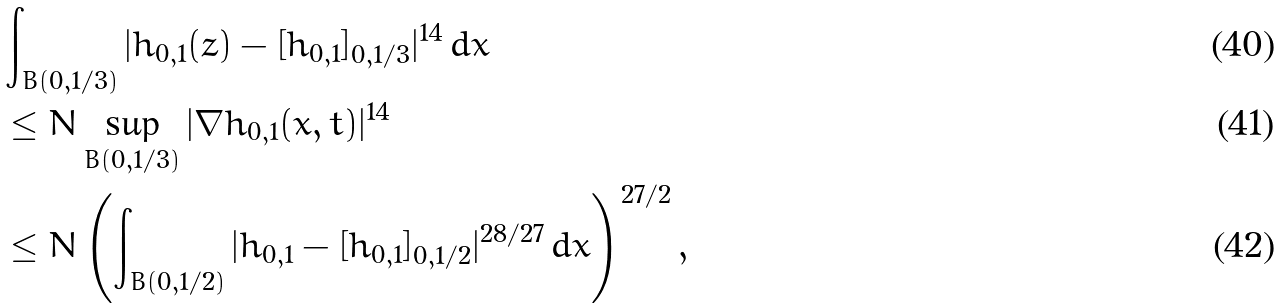Convert formula to latex. <formula><loc_0><loc_0><loc_500><loc_500>& \int _ { B ( 0 , 1 / 3 ) } | \bar { h } _ { 0 , 1 } ( z ) - [ \bar { h } _ { 0 , 1 } ] _ { 0 , 1 / 3 } | ^ { 1 4 } \, d x \\ & \leq N \sup _ { B ( 0 , 1 / 3 ) } | \nabla \bar { h } _ { 0 , 1 } ( x , t ) | ^ { 1 4 } \\ & \leq N \left ( \int _ { B ( 0 , 1 / 2 ) } | \bar { h } _ { 0 , 1 } - [ \bar { h } _ { 0 , 1 } ] _ { 0 , 1 / 2 } | ^ { 2 8 / 2 7 } \, d x \right ) ^ { 2 7 / 2 } ,</formula> 